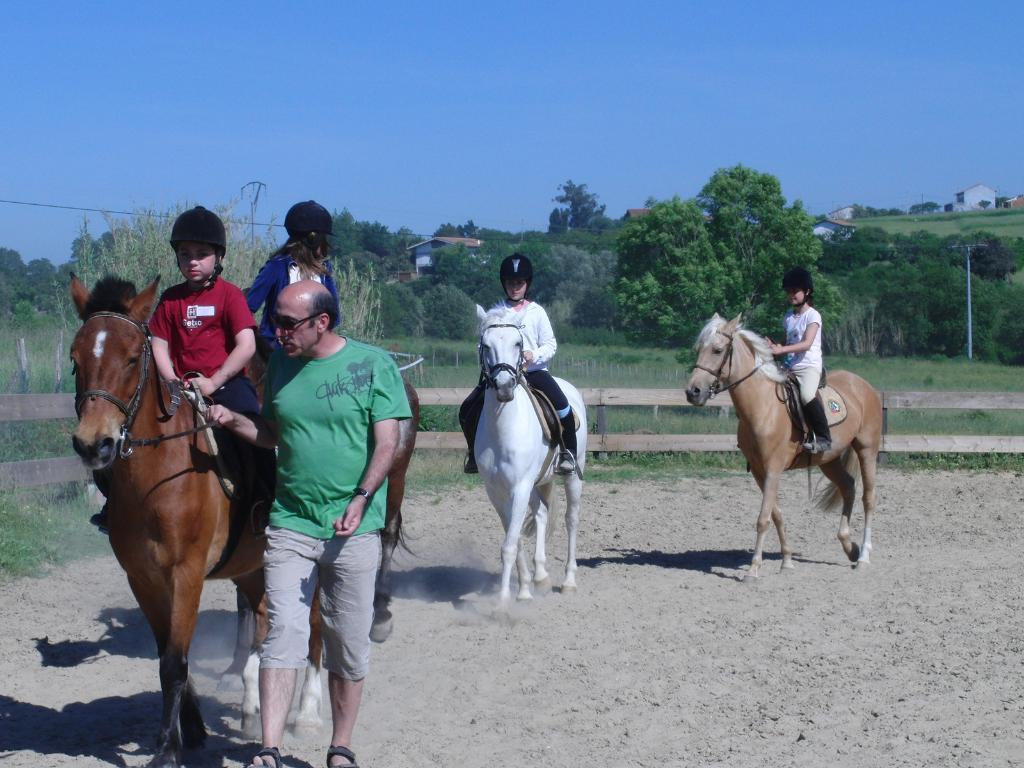What are the people in the image doing? The people in the image are riding horses. Can you describe the man in the image? There is a man walking on the sand floor in the image. What can be seen in the background of the image? There are trees in the background of the image. What is visible above the background? The sky is visible above the background. Where is the swing located in the image? There is no swing present in the image. How many children are playing on the swing in the image? There are no children or swings present in the image. 